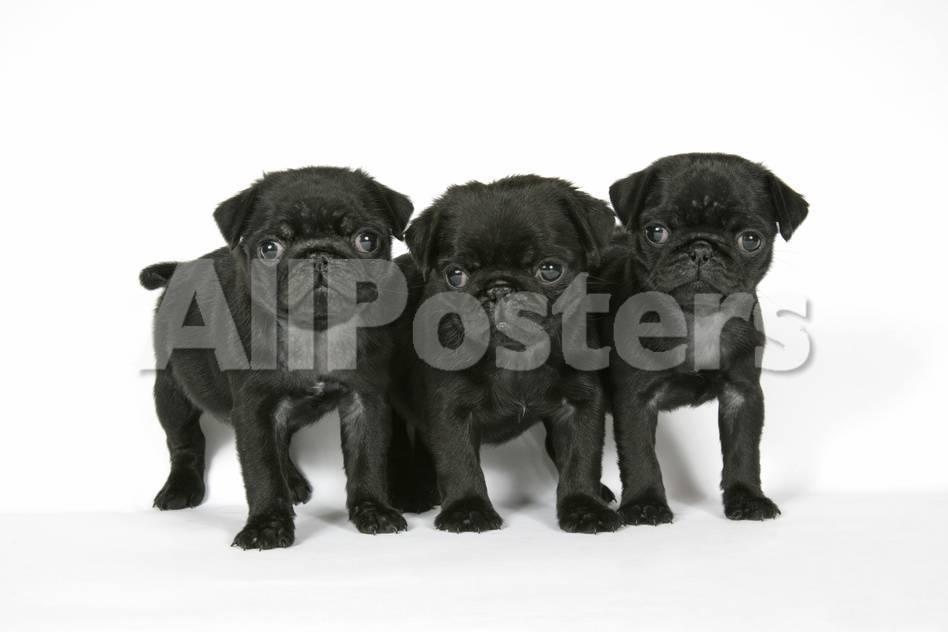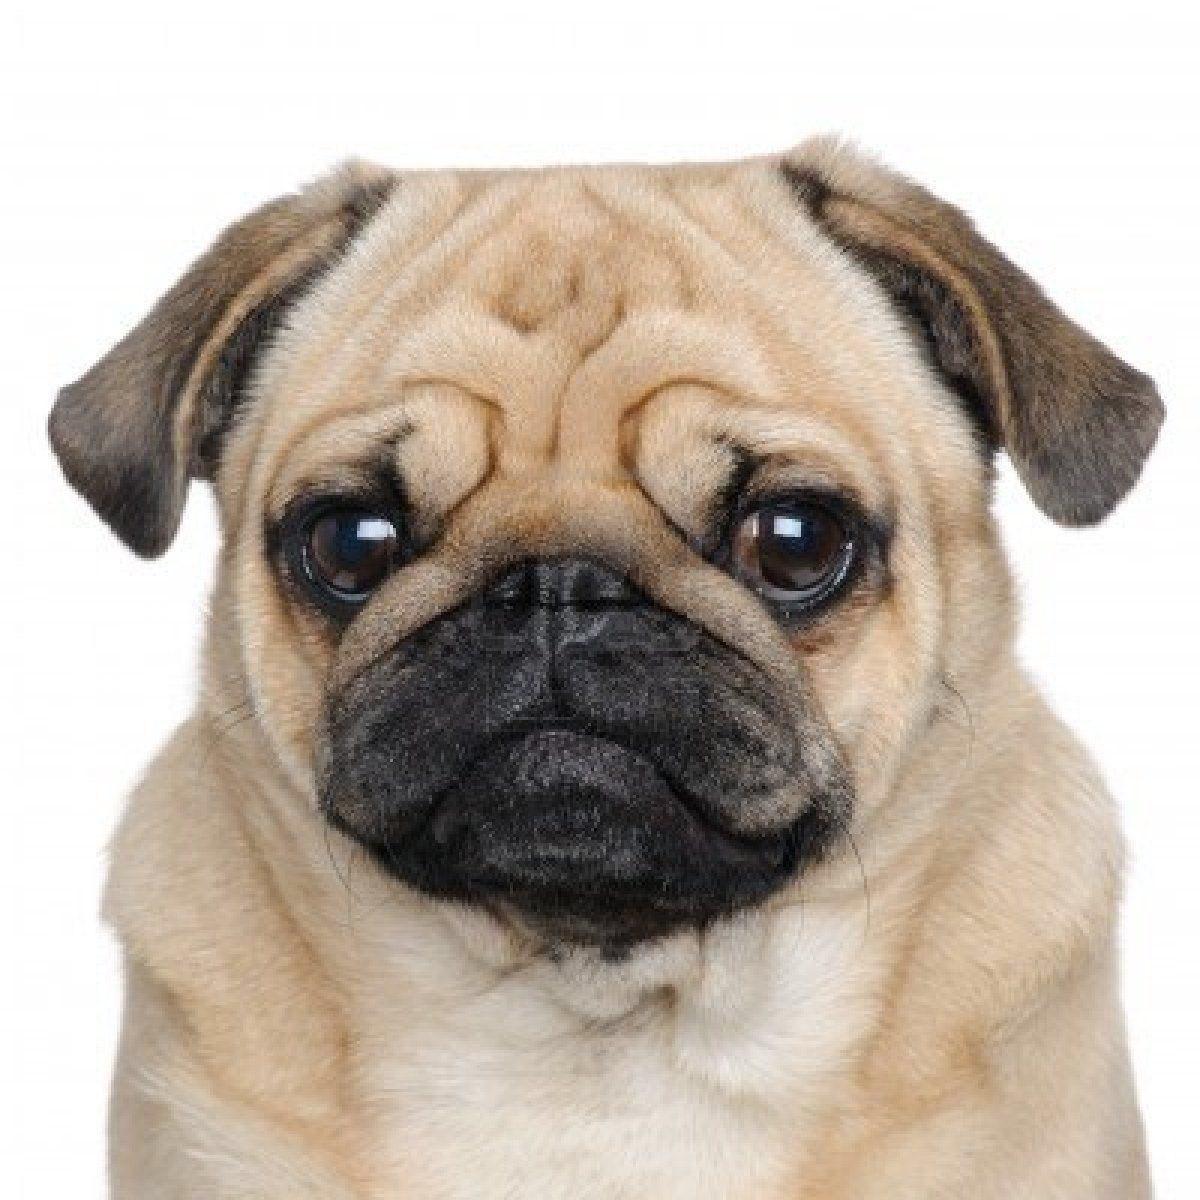The first image is the image on the left, the second image is the image on the right. Assess this claim about the two images: "Each image contains multiple pugs, and one image shows a trio of pugs with a black one in the middle.". Correct or not? Answer yes or no. No. The first image is the image on the left, the second image is the image on the right. For the images shown, is this caption "There are exactly three dogs in the right image." true? Answer yes or no. No. 